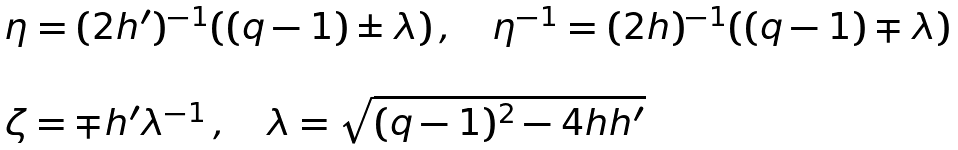<formula> <loc_0><loc_0><loc_500><loc_500>\begin{array} { l } \eta = ( 2 h ^ { \prime } ) ^ { - 1 } ( ( q - 1 ) \pm \lambda ) \, , \quad \eta ^ { - 1 } = ( 2 h ) ^ { - 1 } ( ( q - 1 ) \mp \lambda ) \\ \\ \zeta = \mp h ^ { \prime } \lambda ^ { - 1 } \, , \quad \lambda = \sqrt { ( q - 1 ) ^ { 2 } - 4 h h ^ { \prime } } \end{array}</formula> 